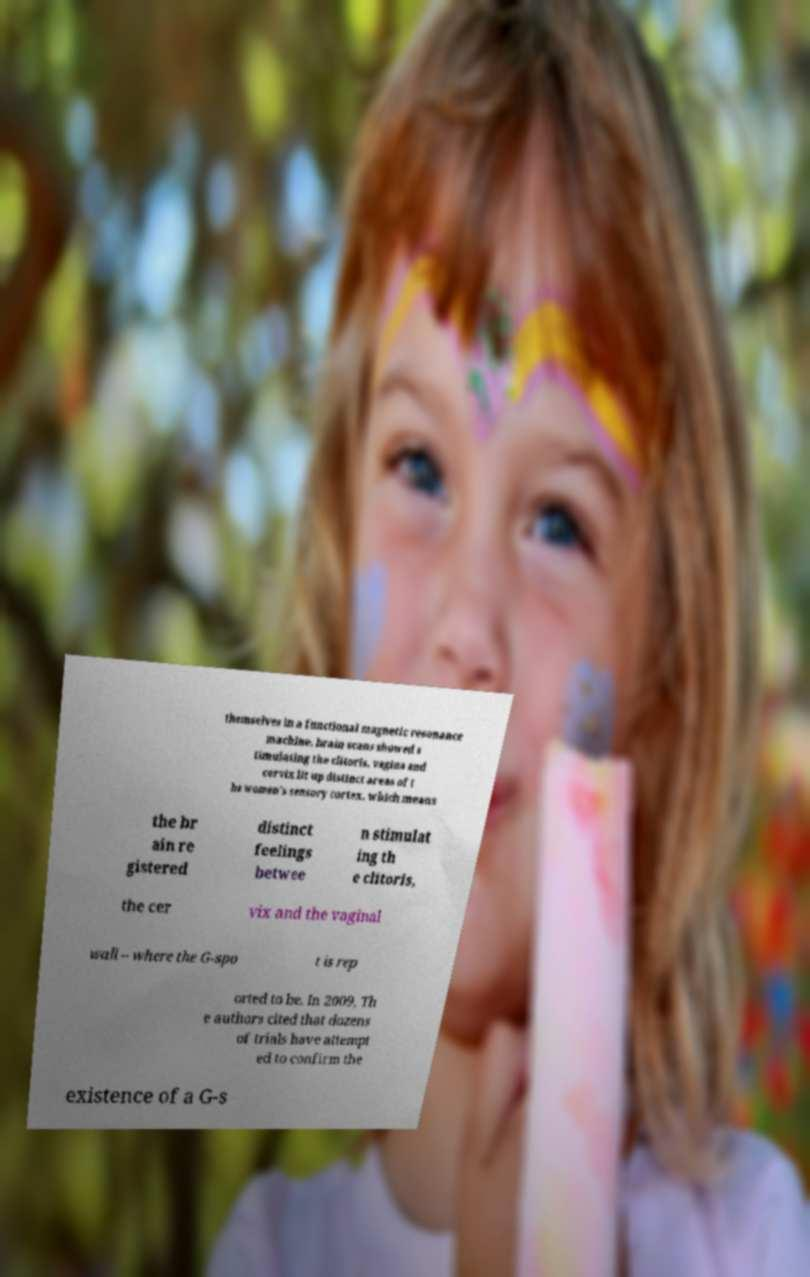Can you accurately transcribe the text from the provided image for me? themselves in a functional magnetic resonance machine, brain scans showed s timulating the clitoris, vagina and cervix lit up distinct areas of t he women's sensory cortex, which means the br ain re gistered distinct feelings betwee n stimulat ing th e clitoris, the cer vix and the vaginal wall – where the G-spo t is rep orted to be. In 2009, Th e authors cited that dozens of trials have attempt ed to confirm the existence of a G-s 